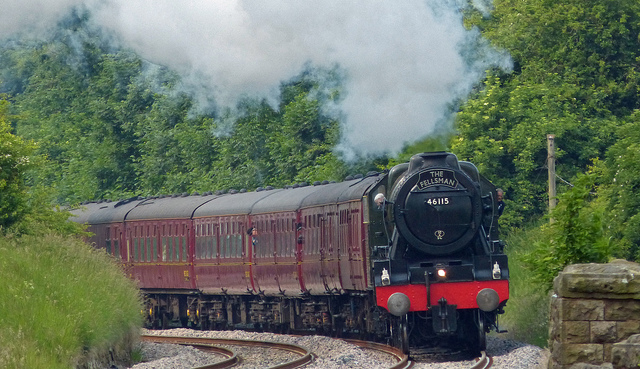Identify the text displayed in this image. THE FELISMAN 46115 